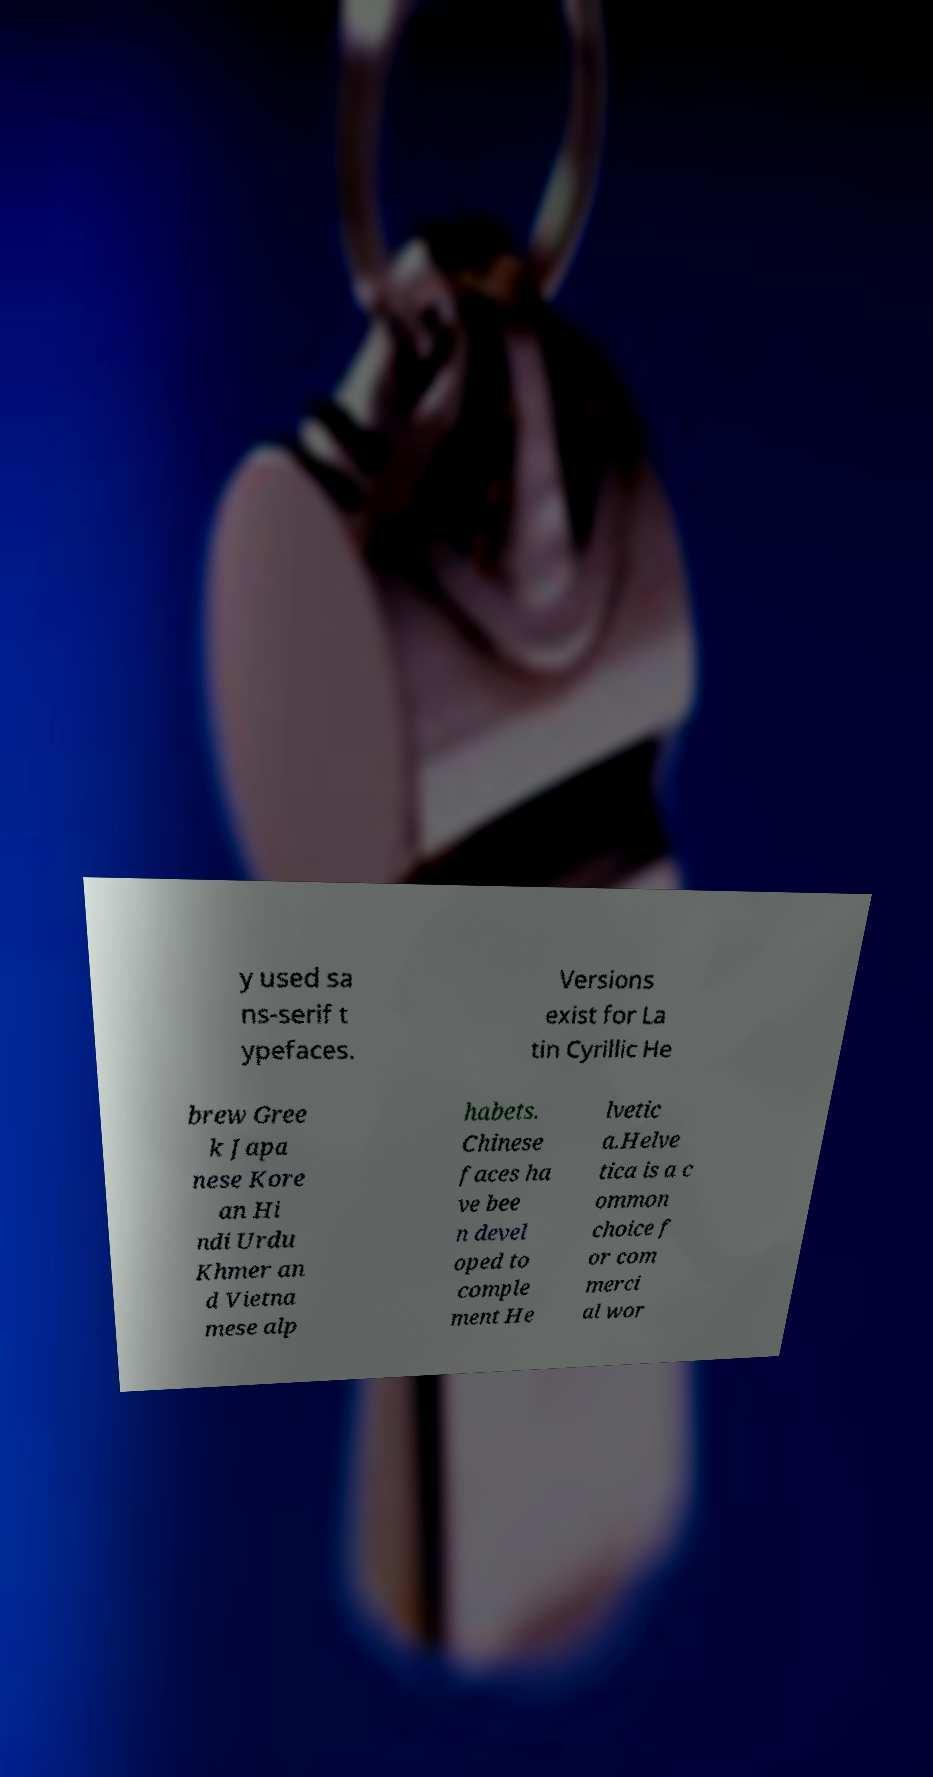What messages or text are displayed in this image? I need them in a readable, typed format. y used sa ns-serif t ypefaces. Versions exist for La tin Cyrillic He brew Gree k Japa nese Kore an Hi ndi Urdu Khmer an d Vietna mese alp habets. Chinese faces ha ve bee n devel oped to comple ment He lvetic a.Helve tica is a c ommon choice f or com merci al wor 